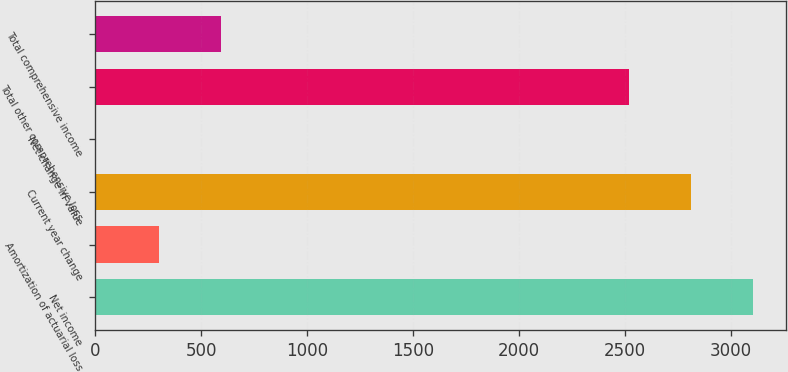Convert chart. <chart><loc_0><loc_0><loc_500><loc_500><bar_chart><fcel>Net income<fcel>Amortization of actuarial loss<fcel>Current year change<fcel>Net change in value<fcel>Total other comprehensive loss<fcel>Total comprehensive income<nl><fcel>3104.8<fcel>298.4<fcel>2810.4<fcel>4<fcel>2516<fcel>592.8<nl></chart> 